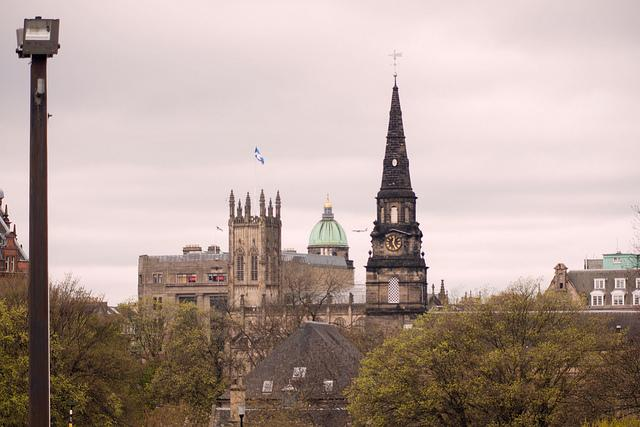What color is the wide dome in the background of the church?

Choices:
A) pink
B) purple
C) blue copper
D) red blue copper 